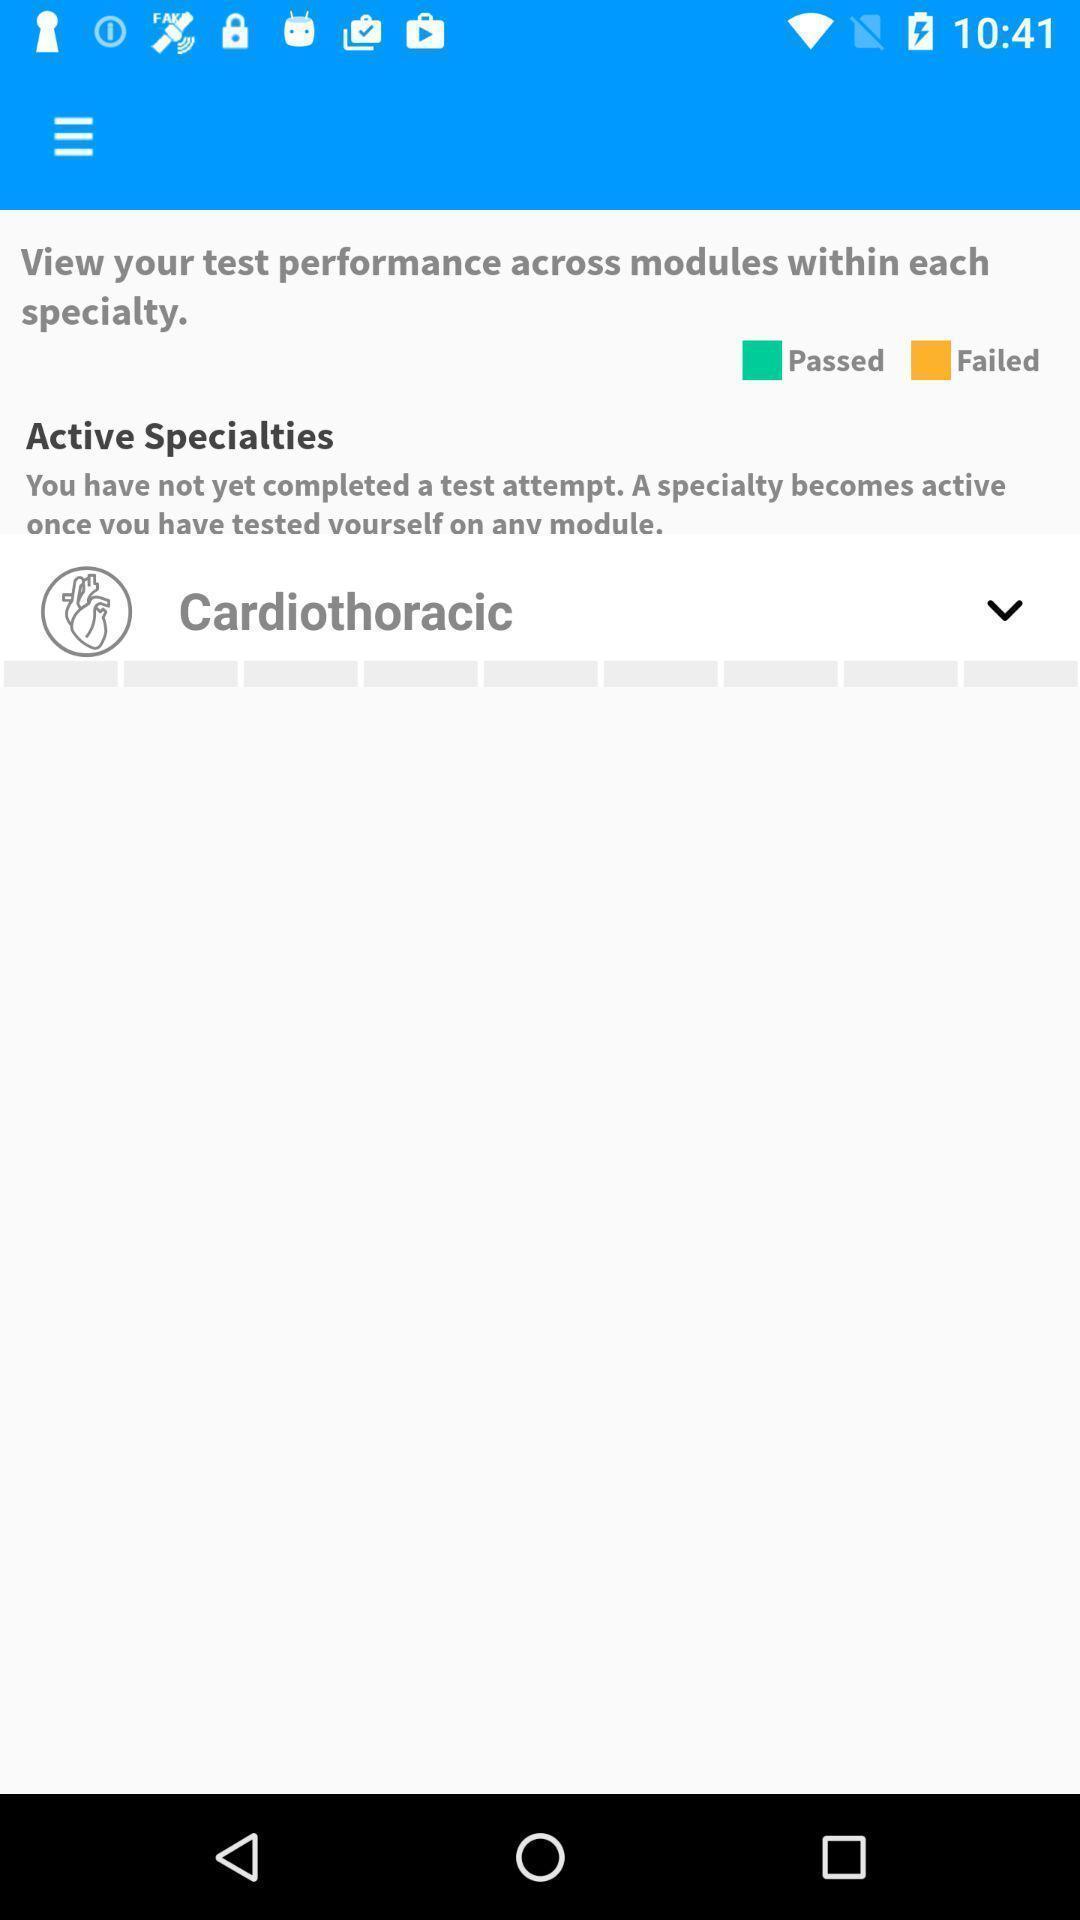Summarize the main components in this picture. Page showing surgical procedure in app. 